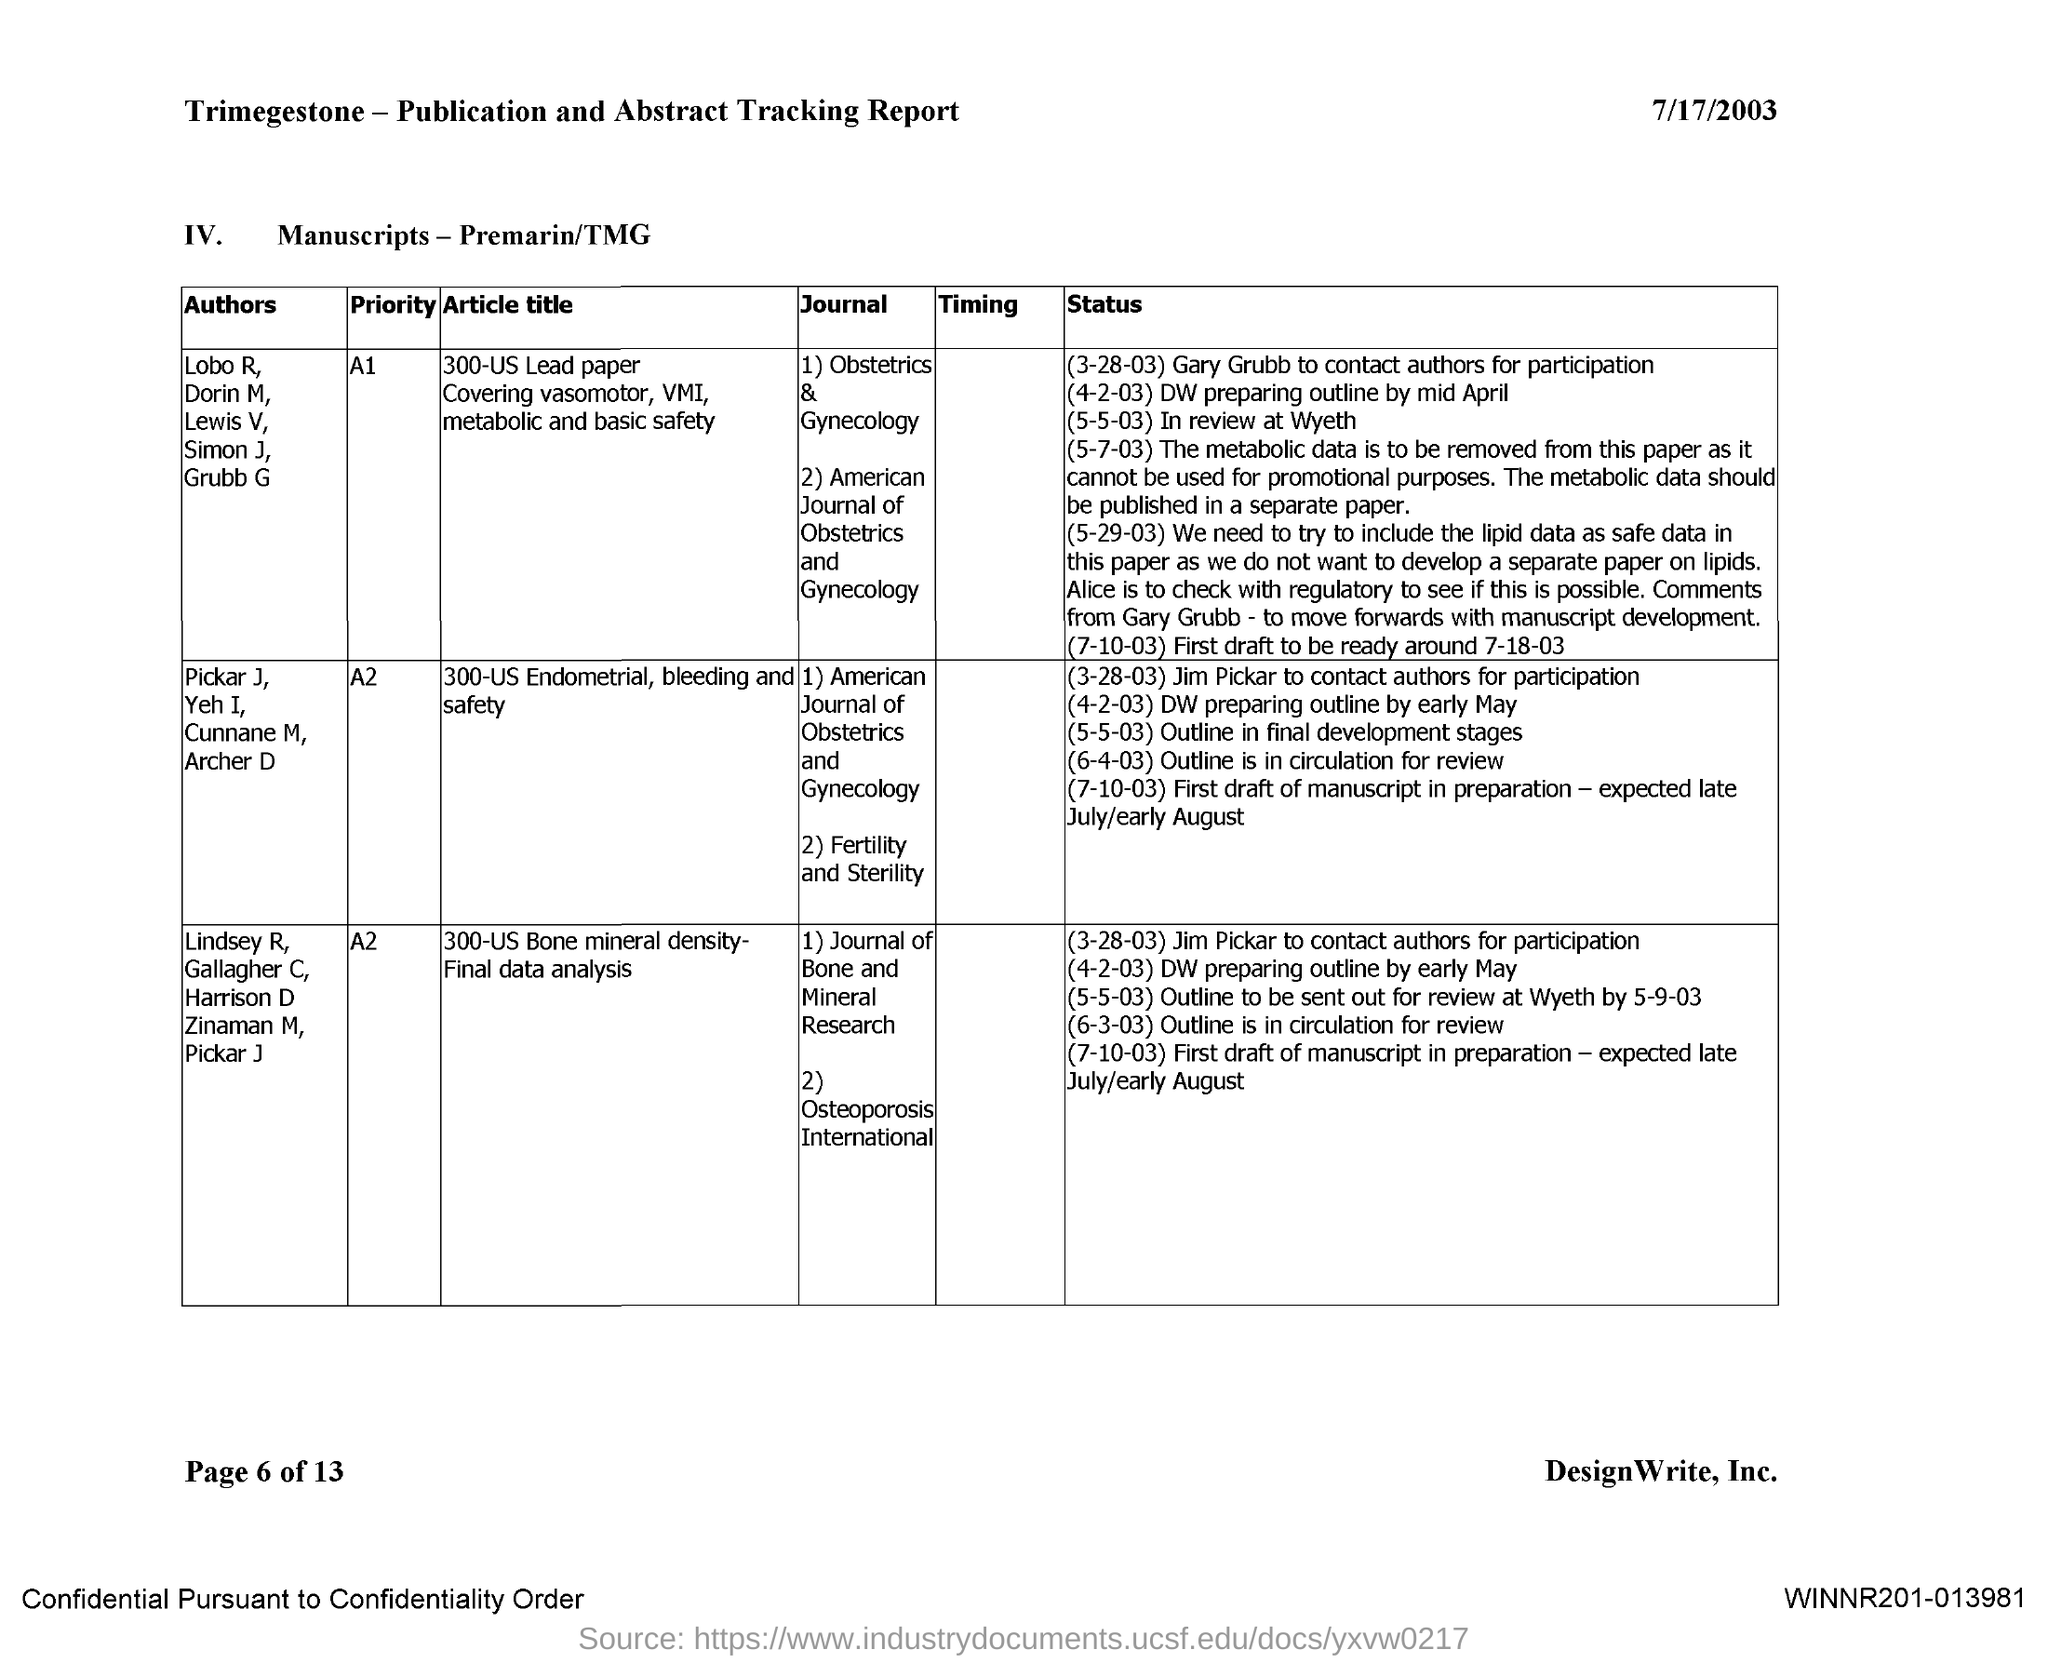Point out several critical features in this image. The document is dated July 17, 2003. 